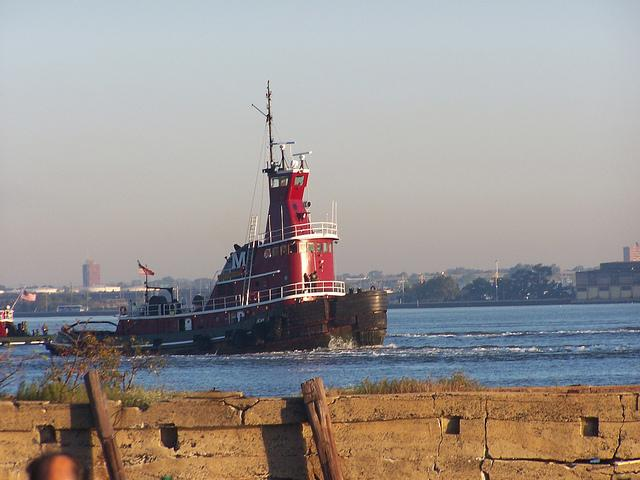The boat here moves under what sort of power?

Choices:
A) solar
B) engine
C) wind
D) tow engine 